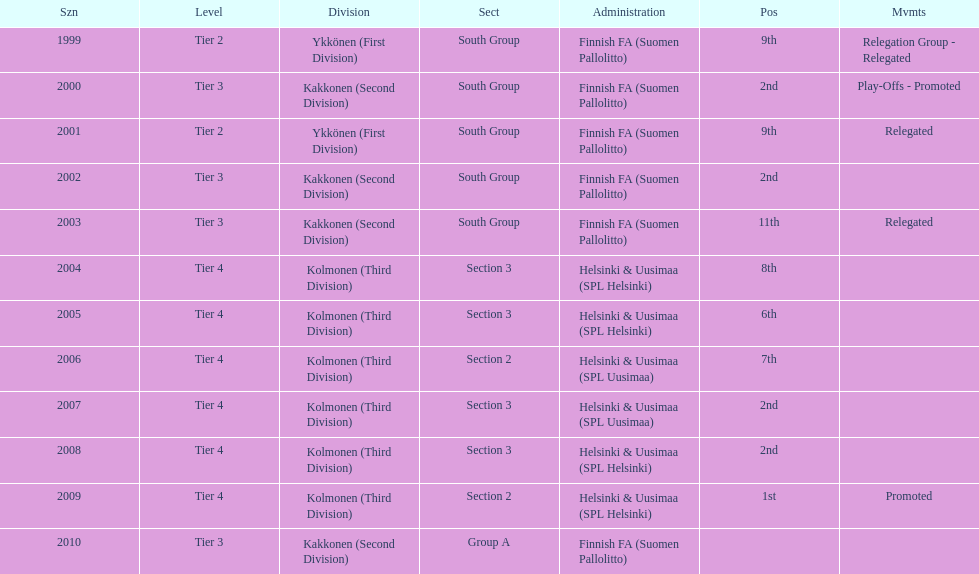What position did this team get after getting 9th place in 1999? 2nd. 